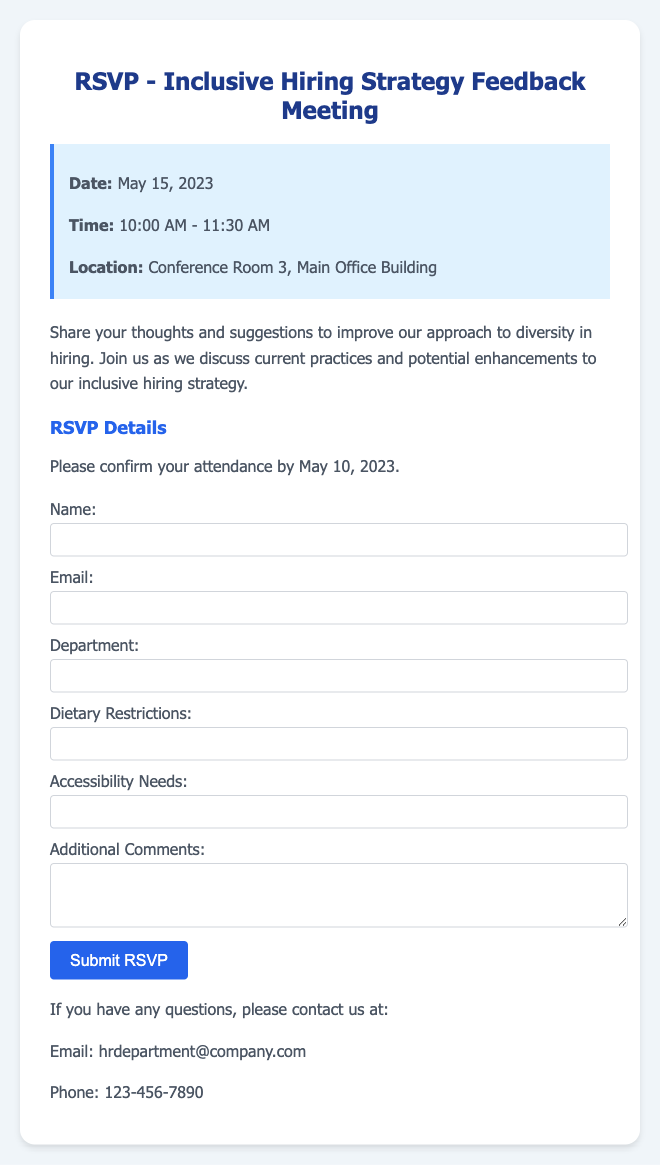What is the date of the meeting? The meeting is scheduled to take place on May 15, 2023, as mentioned in the document.
Answer: May 15, 2023 What time does the meeting start? The document indicates that the meeting starts at 10:00 AM.
Answer: 10:00 AM Where is the meeting location? The meeting is located in Conference Room 3, Main Office Building, as stated in the document.
Answer: Conference Room 3, Main Office Building When is the RSVP deadline? The RSVP deadline is listed as May 10, 2023, in the document.
Answer: May 10, 2023 What is the main purpose of the meeting? The purpose of the meeting is to discuss thoughts and suggestions for improving the approach to diversity in hiring, as noted in the document.
Answer: Improve diversity in hiring What kind of feedback is being sought? The document mentions that thoughts and suggestions to improve the approach to diversity in hiring are being requested.
Answer: Thoughts and suggestions What should attendees include in their RSVP? Attendees should provide their name, email, department, dietary restrictions, accessibility needs, and additional comments in the RSVP form.
Answer: Name, email, department, dietary restrictions, accessibility needs, additional comments Who should be contacted for questions about the meeting? The contact email provided in the document for inquiries is hrdepartment@company.com.
Answer: hrdepartment@company.com What is provided for attendees with specific needs? The document mentions that attendees can report their accessibility needs in the RSVP form.
Answer: Accessibility needs 